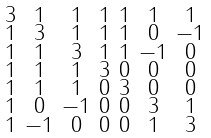Convert formula to latex. <formula><loc_0><loc_0><loc_500><loc_500>\begin{smallmatrix} 3 & 1 & 1 & 1 & 1 & 1 & 1 \\ 1 & 3 & 1 & 1 & 1 & 0 & - 1 \\ 1 & 1 & 3 & 1 & 1 & - 1 & 0 \\ 1 & 1 & 1 & 3 & 0 & 0 & 0 \\ 1 & 1 & 1 & 0 & 3 & 0 & 0 \\ 1 & 0 & - 1 & 0 & 0 & 3 & 1 \\ 1 & - 1 & 0 & 0 & 0 & 1 & 3 \end{smallmatrix}</formula> 